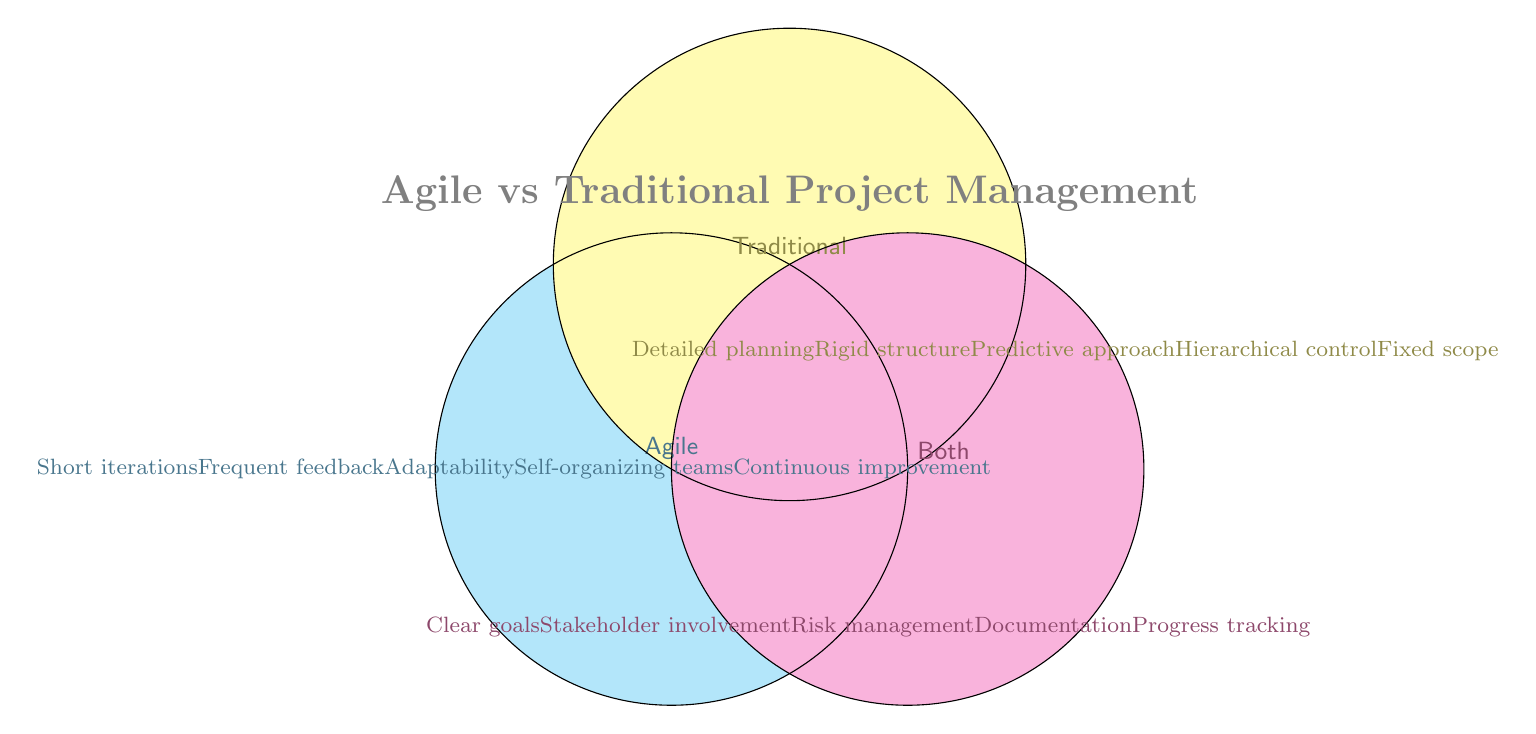What is the title of the Venn Diagram? The title is the large, bold text at the top of the diagram, which combines the key concepts compared in the Venn Diagram.
Answer: Agile vs Traditional Project Management Which section indicates common principles between Agile and traditional project management approaches? The common principles are those that lie in the overlap between the contrasting concepts in a Venn Diagram.
Answer: Both How many principles are listed exclusively for Agile in the diagram? To find the exclusive Agile principles, count the items in the "Agile" section.
Answer: 5 Identify a principle that is unique to traditional project management approaches. Look at the items listed in the "Traditional" section in the Venn Diagram.
Answer: Detailed planning Name two principles that are common to both Agile and traditional project management. Refer to the list of items inside the "Both" section of the Venn Diagram.
Answer: Clear goals, Stakeholder involvement Which methodology emphasizes adaptability? Check the Agile section for principles focused on flexibility and adaptability.
Answer: Agile Is "Progress tracking" unique or shared between Agile and traditional project management? Determine whether "Progress tracking" appears in the overlap section or is exclusive to either approach.
Answer: Shared Compare the number of shared principles to the number of unique Agile principles. Count the principles in the "Both" section and compare with those in the "Agile" section.
Answer: 5 unique Agile, 5 shared Explain how many more unique principles traditional project management has compared to the shared principles. Traditional project management lists five unique principles, whereas there are five shared principles. Calculate the difference.
Answer: 0 more unique List a principle that reflects a key characteristic of Agile methodology but not traditional project management. Find a principle that appears solely in the "Agile" section, highlighting its distinctive approach.
Answer: Frequent feedback 